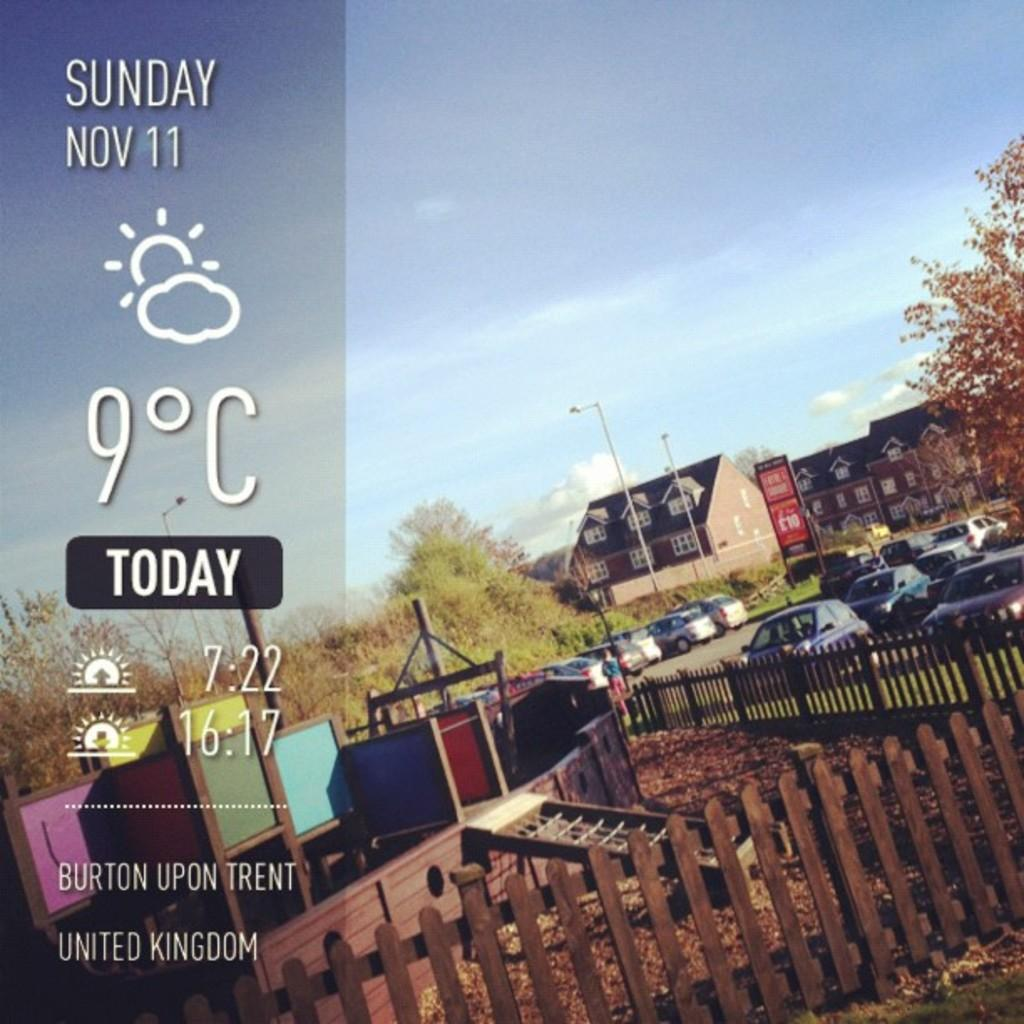Provide a one-sentence caption for the provided image. The temperature in Burton Upon Trent is currently 9 celsius on Sunday, Nov. 11. 